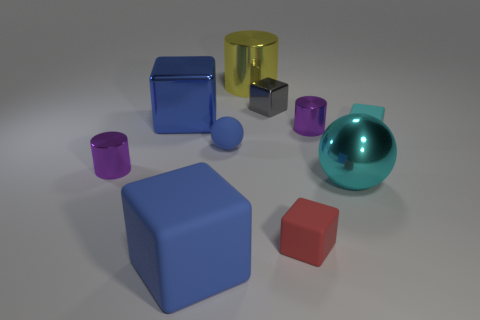Subtract all purple cylinders. How many were subtracted if there are1purple cylinders left? 1 Subtract 1 blocks. How many blocks are left? 4 Subtract all gray metallic blocks. How many blocks are left? 4 Subtract all cyan spheres. Subtract all purple cylinders. How many spheres are left? 1 Subtract all cylinders. How many objects are left? 7 Add 3 tiny blue rubber things. How many tiny blue rubber things exist? 4 Subtract 0 blue cylinders. How many objects are left? 10 Subtract all big balls. Subtract all small red rubber things. How many objects are left? 8 Add 7 purple cylinders. How many purple cylinders are left? 9 